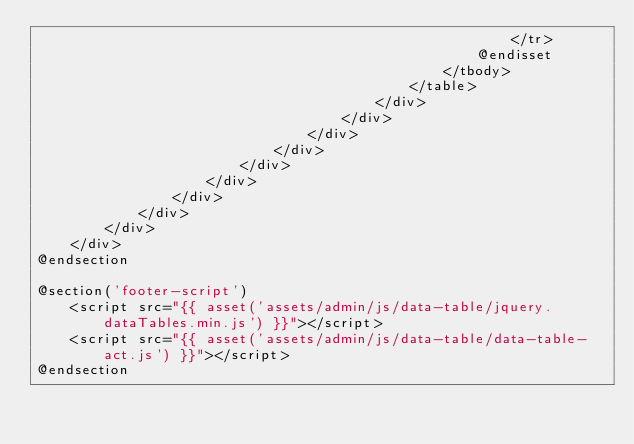Convert code to text. <code><loc_0><loc_0><loc_500><loc_500><_PHP_>                                                        </tr>
                                                    @endisset
                                                </tbody>
                                            </table>
                                        </div>
                                    </div>
                                </div>
                            </div>
                        </div>
                    </div>
                </div>
            </div>
        </div>
    </div>
@endsection

@section('footer-script')
    <script src="{{ asset('assets/admin/js/data-table/jquery.dataTables.min.js') }}"></script>
    <script src="{{ asset('assets/admin/js/data-table/data-table-act.js') }}"></script>
@endsection</code> 